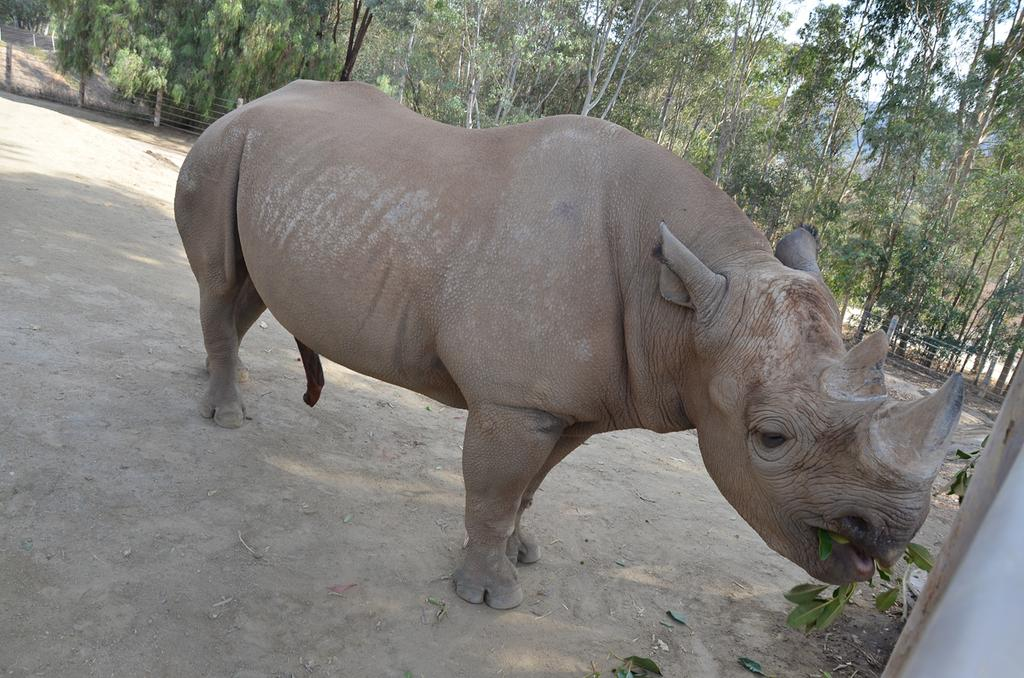What type of creature is present in the image? There is an animal in the image. How is the animal positioned in the image? The animal is standing on the ground. What can be seen in the background of the image? There is a fence and trees in the background of the image. Can you tell me how many fish are swimming in the air in the image? There are no fish present in the image, and fish cannot swim in the air. 